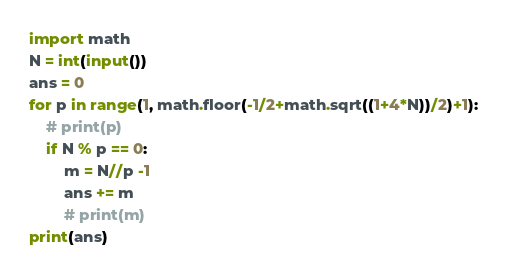Convert code to text. <code><loc_0><loc_0><loc_500><loc_500><_Python_>import math
N = int(input())
ans = 0
for p in range(1, math.floor(-1/2+math.sqrt((1+4*N))/2)+1):
    # print(p)
    if N % p == 0:
        m = N//p -1
        ans += m
        # print(m)
print(ans)</code> 